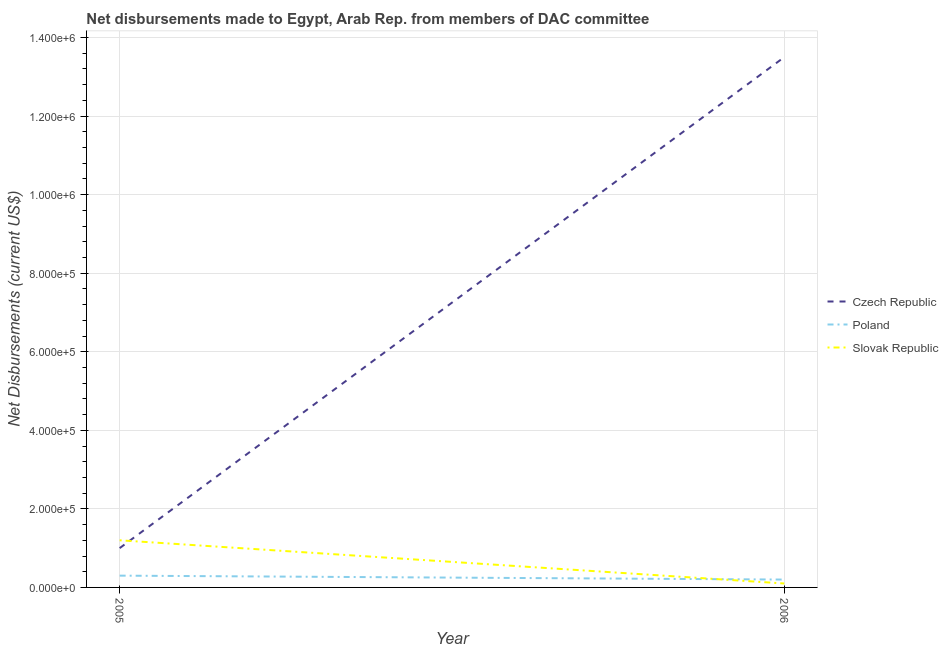Is the number of lines equal to the number of legend labels?
Provide a short and direct response. Yes. What is the net disbursements made by slovak republic in 2006?
Offer a very short reply. 10000. Across all years, what is the maximum net disbursements made by czech republic?
Offer a terse response. 1.35e+06. Across all years, what is the minimum net disbursements made by czech republic?
Keep it short and to the point. 1.00e+05. In which year was the net disbursements made by poland maximum?
Your answer should be very brief. 2005. What is the total net disbursements made by slovak republic in the graph?
Make the answer very short. 1.30e+05. What is the difference between the net disbursements made by poland in 2005 and that in 2006?
Offer a very short reply. 10000. What is the difference between the net disbursements made by czech republic in 2006 and the net disbursements made by poland in 2005?
Your response must be concise. 1.32e+06. What is the average net disbursements made by czech republic per year?
Offer a terse response. 7.25e+05. In the year 2006, what is the difference between the net disbursements made by czech republic and net disbursements made by poland?
Offer a terse response. 1.33e+06. In how many years, is the net disbursements made by czech republic greater than 240000 US$?
Offer a very short reply. 1. What is the ratio of the net disbursements made by czech republic in 2005 to that in 2006?
Ensure brevity in your answer.  0.07. In how many years, is the net disbursements made by czech republic greater than the average net disbursements made by czech republic taken over all years?
Provide a short and direct response. 1. Is it the case that in every year, the sum of the net disbursements made by czech republic and net disbursements made by poland is greater than the net disbursements made by slovak republic?
Give a very brief answer. Yes. Are the values on the major ticks of Y-axis written in scientific E-notation?
Offer a terse response. Yes. How many legend labels are there?
Your answer should be very brief. 3. How are the legend labels stacked?
Keep it short and to the point. Vertical. What is the title of the graph?
Keep it short and to the point. Net disbursements made to Egypt, Arab Rep. from members of DAC committee. What is the label or title of the Y-axis?
Give a very brief answer. Net Disbursements (current US$). What is the Net Disbursements (current US$) in Poland in 2005?
Keep it short and to the point. 3.00e+04. What is the Net Disbursements (current US$) of Slovak Republic in 2005?
Make the answer very short. 1.20e+05. What is the Net Disbursements (current US$) of Czech Republic in 2006?
Your answer should be compact. 1.35e+06. Across all years, what is the maximum Net Disbursements (current US$) in Czech Republic?
Your response must be concise. 1.35e+06. Across all years, what is the maximum Net Disbursements (current US$) in Poland?
Keep it short and to the point. 3.00e+04. Across all years, what is the maximum Net Disbursements (current US$) of Slovak Republic?
Make the answer very short. 1.20e+05. Across all years, what is the minimum Net Disbursements (current US$) in Czech Republic?
Provide a short and direct response. 1.00e+05. Across all years, what is the minimum Net Disbursements (current US$) of Slovak Republic?
Make the answer very short. 10000. What is the total Net Disbursements (current US$) of Czech Republic in the graph?
Give a very brief answer. 1.45e+06. What is the total Net Disbursements (current US$) in Poland in the graph?
Offer a terse response. 5.00e+04. What is the total Net Disbursements (current US$) in Slovak Republic in the graph?
Make the answer very short. 1.30e+05. What is the difference between the Net Disbursements (current US$) in Czech Republic in 2005 and that in 2006?
Provide a short and direct response. -1.25e+06. What is the difference between the Net Disbursements (current US$) in Poland in 2005 and that in 2006?
Your response must be concise. 10000. What is the difference between the Net Disbursements (current US$) of Slovak Republic in 2005 and that in 2006?
Make the answer very short. 1.10e+05. What is the difference between the Net Disbursements (current US$) of Czech Republic in 2005 and the Net Disbursements (current US$) of Slovak Republic in 2006?
Offer a terse response. 9.00e+04. What is the average Net Disbursements (current US$) in Czech Republic per year?
Provide a short and direct response. 7.25e+05. What is the average Net Disbursements (current US$) in Poland per year?
Give a very brief answer. 2.50e+04. What is the average Net Disbursements (current US$) of Slovak Republic per year?
Provide a succinct answer. 6.50e+04. In the year 2005, what is the difference between the Net Disbursements (current US$) of Czech Republic and Net Disbursements (current US$) of Slovak Republic?
Ensure brevity in your answer.  -2.00e+04. In the year 2006, what is the difference between the Net Disbursements (current US$) of Czech Republic and Net Disbursements (current US$) of Poland?
Provide a succinct answer. 1.33e+06. In the year 2006, what is the difference between the Net Disbursements (current US$) of Czech Republic and Net Disbursements (current US$) of Slovak Republic?
Offer a terse response. 1.34e+06. In the year 2006, what is the difference between the Net Disbursements (current US$) in Poland and Net Disbursements (current US$) in Slovak Republic?
Give a very brief answer. 10000. What is the ratio of the Net Disbursements (current US$) in Czech Republic in 2005 to that in 2006?
Offer a very short reply. 0.07. What is the difference between the highest and the second highest Net Disbursements (current US$) of Czech Republic?
Offer a terse response. 1.25e+06. What is the difference between the highest and the second highest Net Disbursements (current US$) of Slovak Republic?
Make the answer very short. 1.10e+05. What is the difference between the highest and the lowest Net Disbursements (current US$) of Czech Republic?
Keep it short and to the point. 1.25e+06. What is the difference between the highest and the lowest Net Disbursements (current US$) in Poland?
Provide a succinct answer. 10000. 